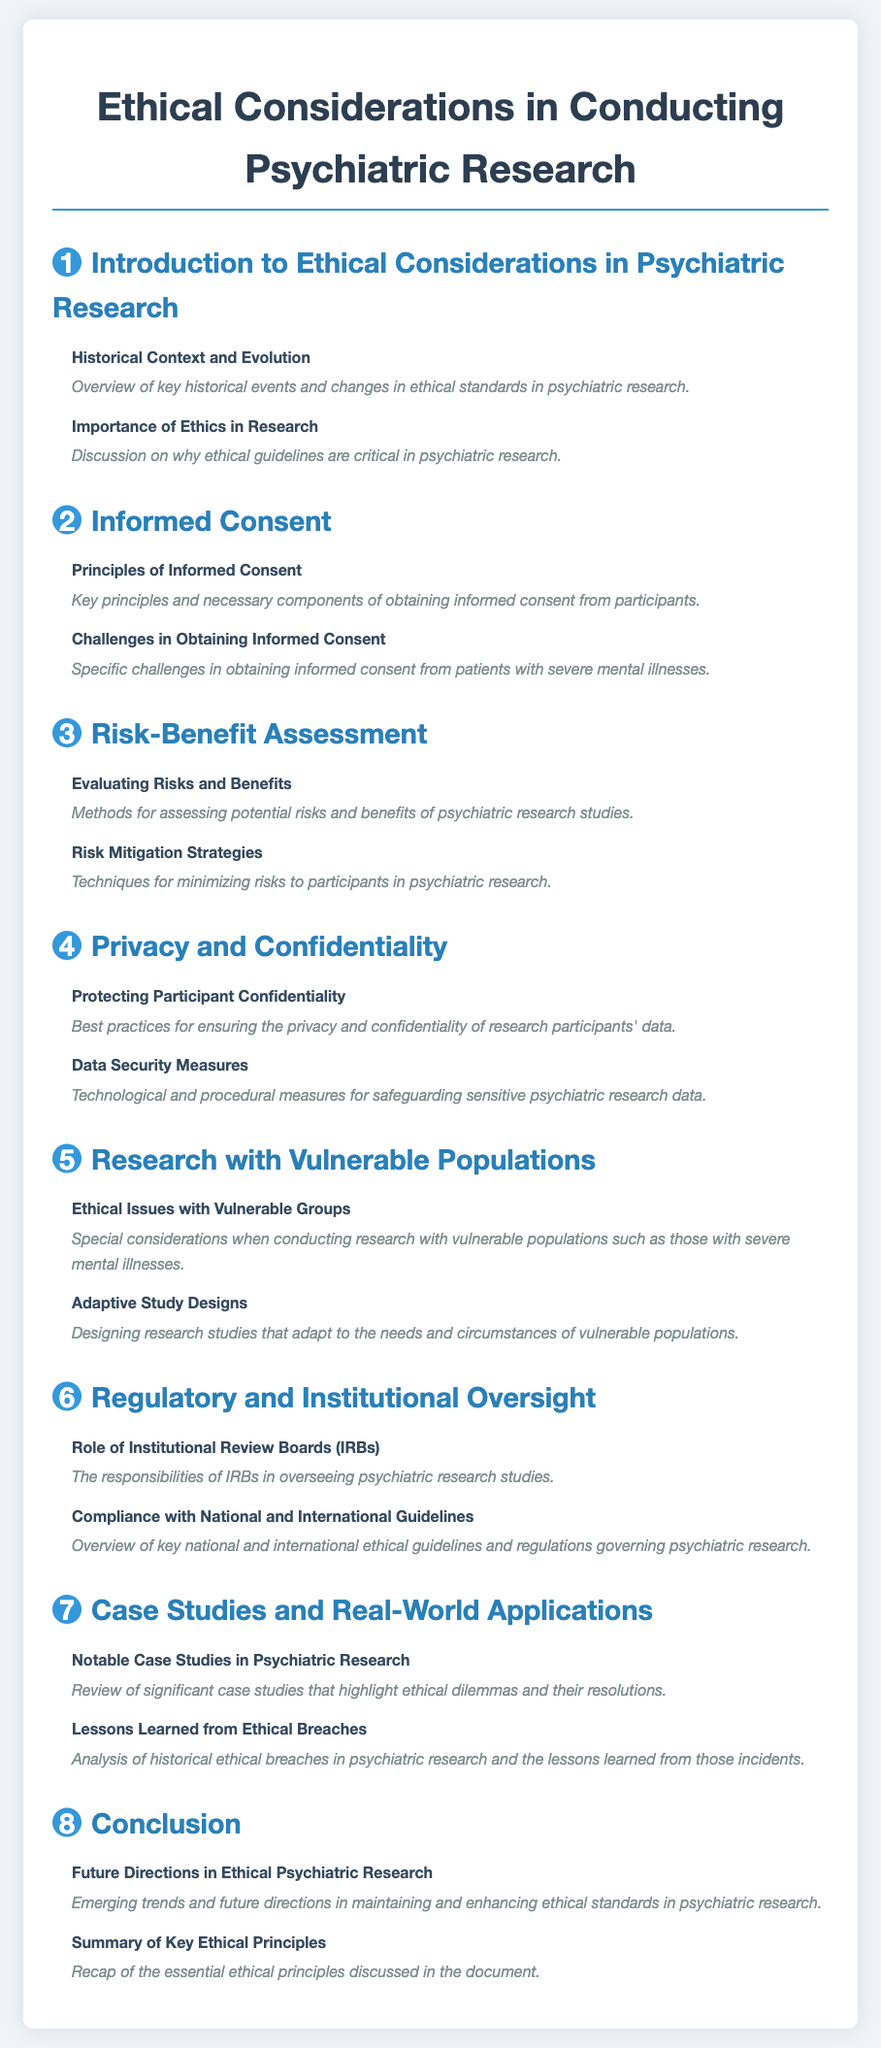What is the title of the document? The title is stated at the beginning of the document.
Answer: Ethical Considerations in Conducting Psychiatric Research How many chapters are there in total? The number of chapters can be counted from the table of contents section.
Answer: 8 What is the first subsection under Informed Consent? The subsections are listed under each chapter, starting with the first one.
Answer: Principles of Informed Consent What chapter discusses Risk Mitigation Strategies? The chapters can be identified by their titles in the table of contents.
Answer: Chapter 3 What ethical issue is highlighted in research with vulnerable populations? This subsection discusses specific considerations for vulnerable groups in research.
Answer: Ethical Issues with Vulnerable Groups Which chapter covers the role of Institutional Review Boards? The chapter titles indicate the focus of each chapter.
Answer: Chapter 6 What does the final chapter summarize? The content of the last chapter is outlined in the table of contents.
Answer: Summary of Key Ethical Principles What is a key focus in the introduction to the document? The introduction highlights foundational concepts regarding ethics in research.
Answer: Importance of Ethics in Research 